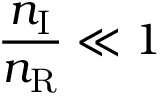<formula> <loc_0><loc_0><loc_500><loc_500>\frac { n _ { I } } { n _ { R } } \ll 1</formula> 